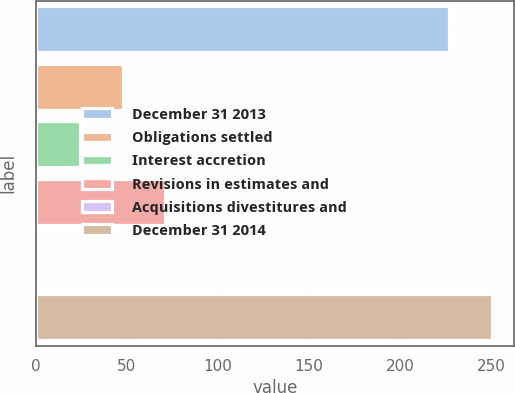<chart> <loc_0><loc_0><loc_500><loc_500><bar_chart><fcel>December 31 2013<fcel>Obligations settled<fcel>Interest accretion<fcel>Revisions in estimates and<fcel>Acquisitions divestitures and<fcel>December 31 2014<nl><fcel>227<fcel>47.8<fcel>24.4<fcel>71.2<fcel>1<fcel>250.4<nl></chart> 